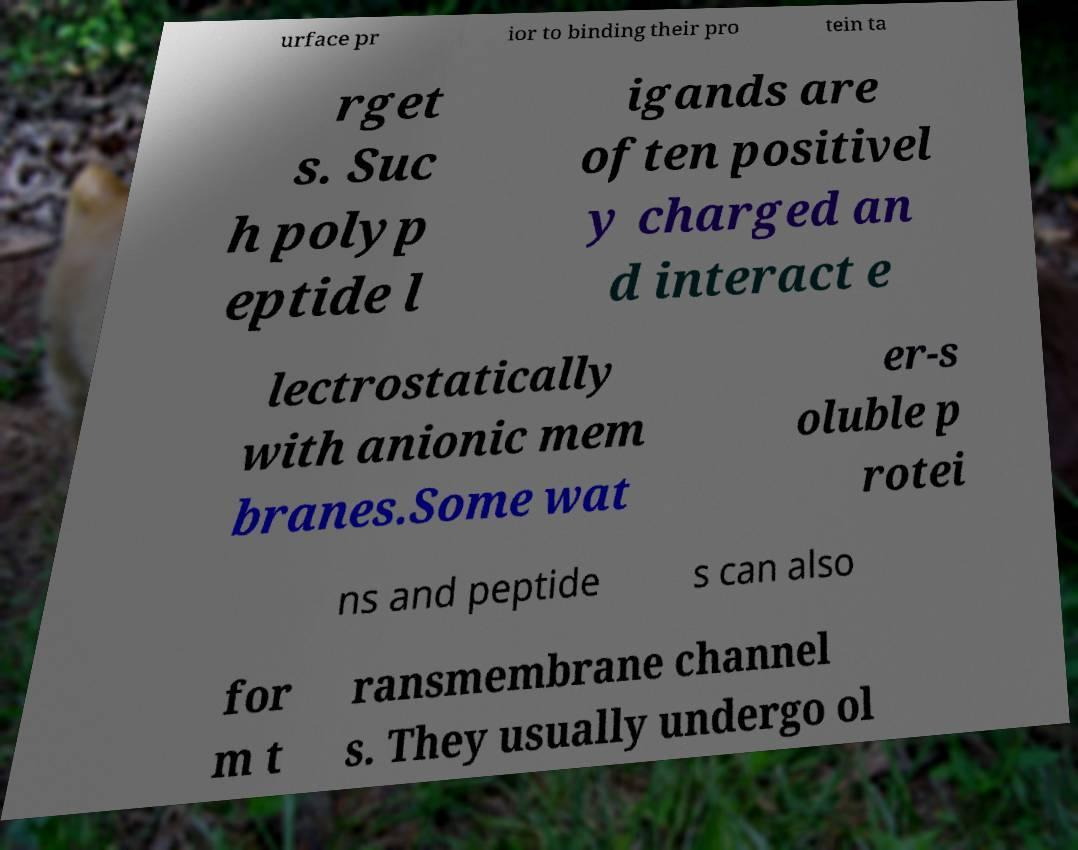Please read and relay the text visible in this image. What does it say? urface pr ior to binding their pro tein ta rget s. Suc h polyp eptide l igands are often positivel y charged an d interact e lectrostatically with anionic mem branes.Some wat er-s oluble p rotei ns and peptide s can also for m t ransmembrane channel s. They usually undergo ol 